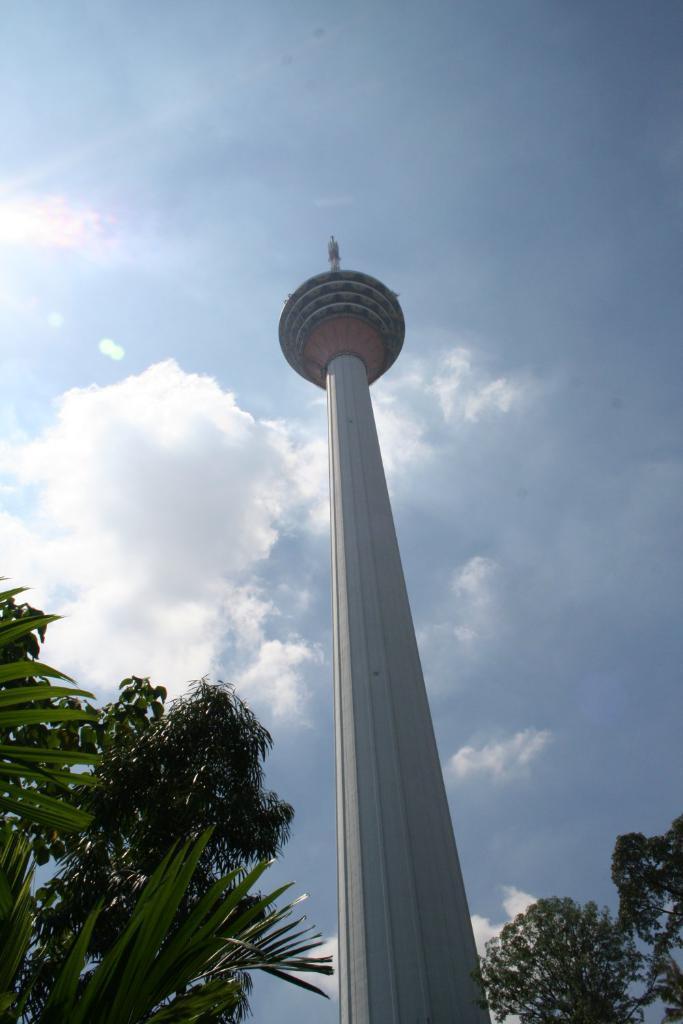Please provide a concise description of this image. This picture is clicked outside. In the foreground we can see the trees. In the center we can see a minaret. In the background we can see the sky with the clouds. 